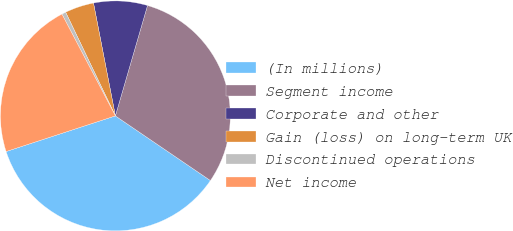Convert chart to OTSL. <chart><loc_0><loc_0><loc_500><loc_500><pie_chart><fcel>(In millions)<fcel>Segment income<fcel>Corporate and other<fcel>Gain (loss) on long-term UK<fcel>Discontinued operations<fcel>Net income<nl><fcel>35.47%<fcel>30.0%<fcel>7.56%<fcel>4.07%<fcel>0.58%<fcel>22.32%<nl></chart> 